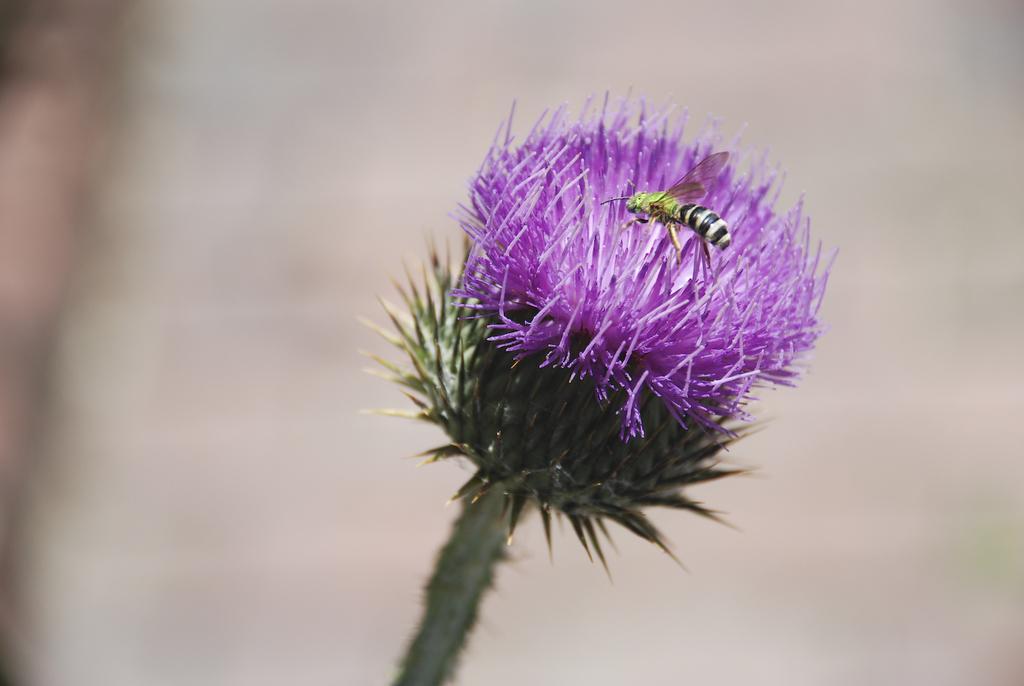Please provide a concise description of this image. In this image we can see a flower to a plant. An insect is sitting on the flower. There is a blur background in the image. 